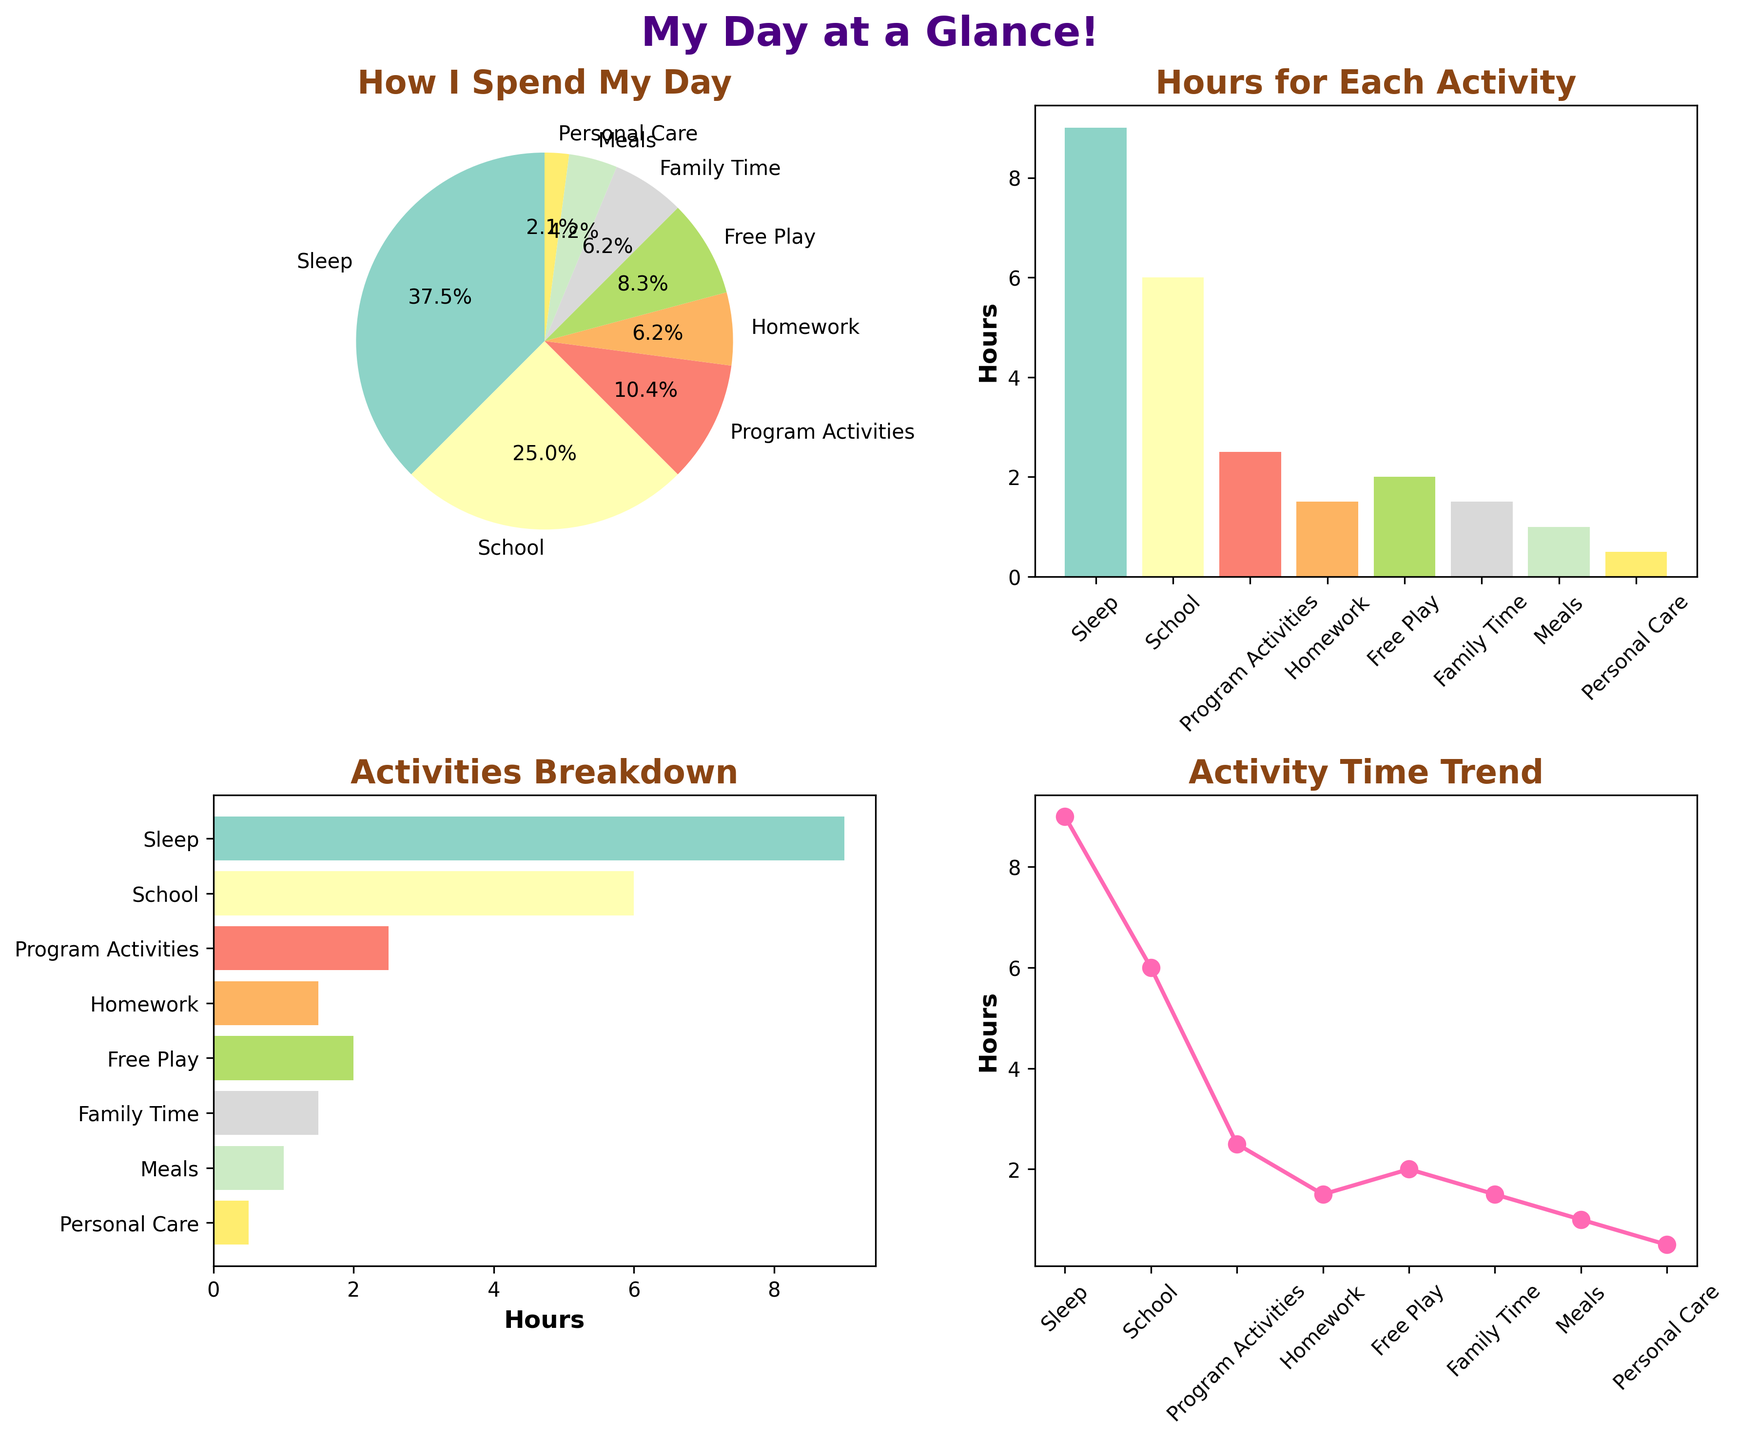How many activities are listed in the pie chart? The pie chart has different sections, each representing an activity. Count each section to get the total number.
Answer: 8 What is the largest activity in terms of hours spent according to the bar chart? Look at the bar chart and identify the tallest bar, which represents the activity with the most hours.
Answer: Sleep How many more hours are spent on program activities than on family time? Subtract the hours spent on family time from the hours spent on program activities (2.5 - 1.5).
Answer: 1 Which activity has the fewest hours according to the horizontal bar chart? Look at the horizontal bar chart and find the shortest bar, which represents the activity with the least hours.
Answer: Personal Care What percentage of the day is spent sleeping according to the pie chart? The pie chart shows the percentage for each activity. Look for the section labeled "Sleep" and read the percentage.
Answer: 37.5% By how many hours does school time exceed homework time? Subtract the hours spent on homework from the hours spent on school (6 - 1.5).
Answer: 4.5 Which activity is the second most popular in terms of hours, according to the line chart? Check the line chart and look for the activity represented by the second highest point on the line.
Answer: School Compare and find out whether more time is spent on free play or on family time. Look at both the free play and family time data points in any of the charts and compare their values. Free Play has 2 hours, while Family Time has 1.5 hours.
Answer: Free Play What is the total number of hours spent on meals and personal care each day? Add the hours of meals and personal care together (1 + 0.5).
Answer: 1.5 Which chart type visually represents how each activity is distributed across a typical day? Among the different charts, the pie chart best shows how the entire day is divided among various activities because it provides a visual representation of proportions.
Answer: Pie Chart 